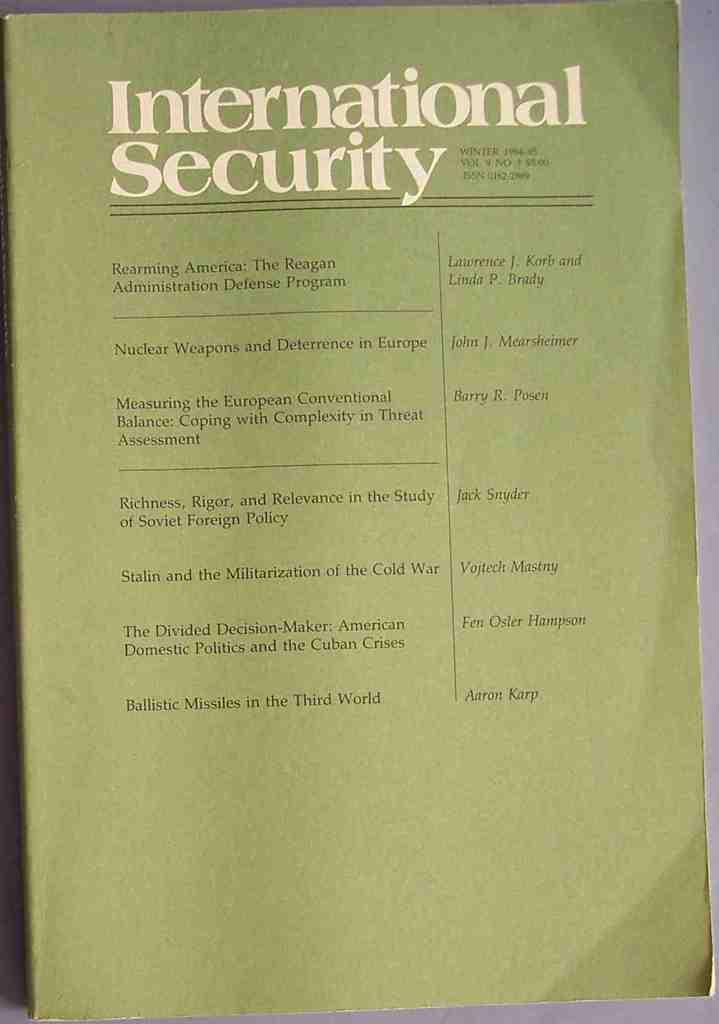<image>
Summarize the visual content of the image. The winter 1984-85 issue of International Security includes work by Jack Snyder. 